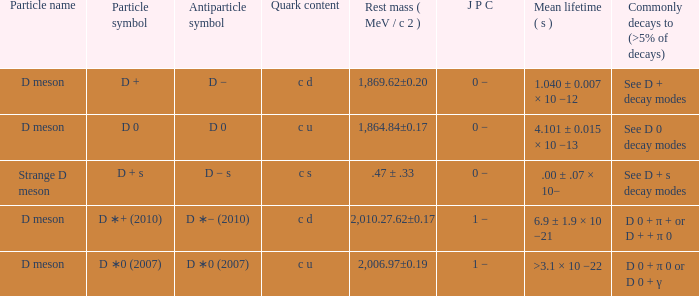What is the antiparticle symbol with a rest mess (mev/c2) of .47 ± .33? D − s. 